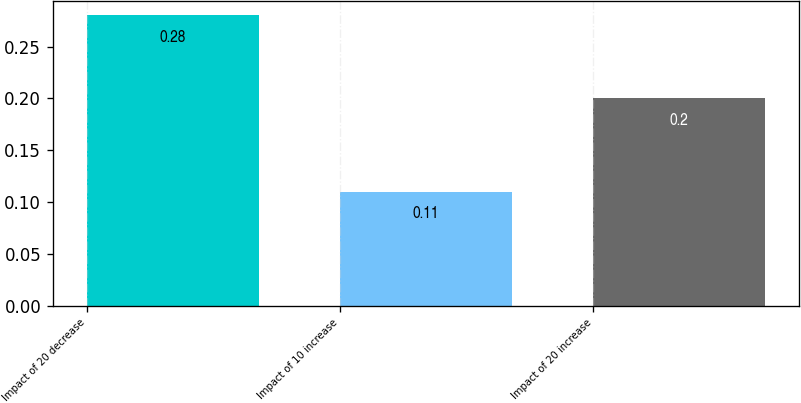Convert chart. <chart><loc_0><loc_0><loc_500><loc_500><bar_chart><fcel>Impact of 20 decrease<fcel>Impact of 10 increase<fcel>Impact of 20 increase<nl><fcel>0.28<fcel>0.11<fcel>0.2<nl></chart> 